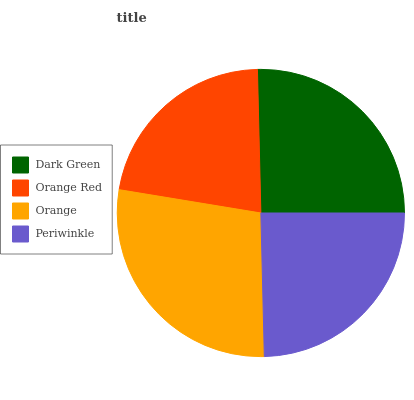Is Orange Red the minimum?
Answer yes or no. Yes. Is Orange the maximum?
Answer yes or no. Yes. Is Orange the minimum?
Answer yes or no. No. Is Orange Red the maximum?
Answer yes or no. No. Is Orange greater than Orange Red?
Answer yes or no. Yes. Is Orange Red less than Orange?
Answer yes or no. Yes. Is Orange Red greater than Orange?
Answer yes or no. No. Is Orange less than Orange Red?
Answer yes or no. No. Is Dark Green the high median?
Answer yes or no. Yes. Is Periwinkle the low median?
Answer yes or no. Yes. Is Orange Red the high median?
Answer yes or no. No. Is Orange Red the low median?
Answer yes or no. No. 